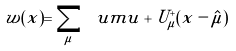<formula> <loc_0><loc_0><loc_500><loc_500>w ( x ) = \sum _ { \mu } \ u m u + U ^ { + } _ { \mu } ( x - \hat { \mu } )</formula> 